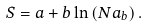Convert formula to latex. <formula><loc_0><loc_0><loc_500><loc_500>S = a + b \ln \left ( N a _ { b } \right ) .</formula> 